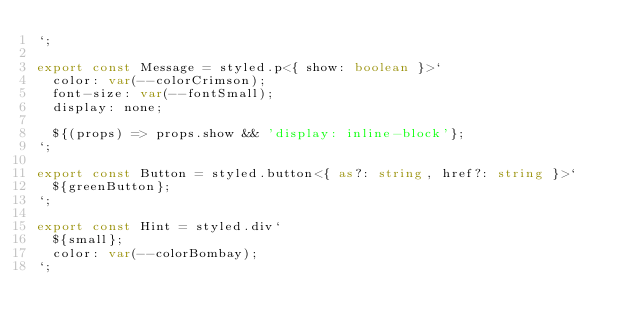Convert code to text. <code><loc_0><loc_0><loc_500><loc_500><_TypeScript_>`;

export const Message = styled.p<{ show: boolean }>`
  color: var(--colorCrimson);
  font-size: var(--fontSmall);
  display: none;
  
  ${(props) => props.show && 'display: inline-block'};
`;

export const Button = styled.button<{ as?: string, href?: string }>`
  ${greenButton};
`;

export const Hint = styled.div`
  ${small};
  color: var(--colorBombay);
`;
</code> 